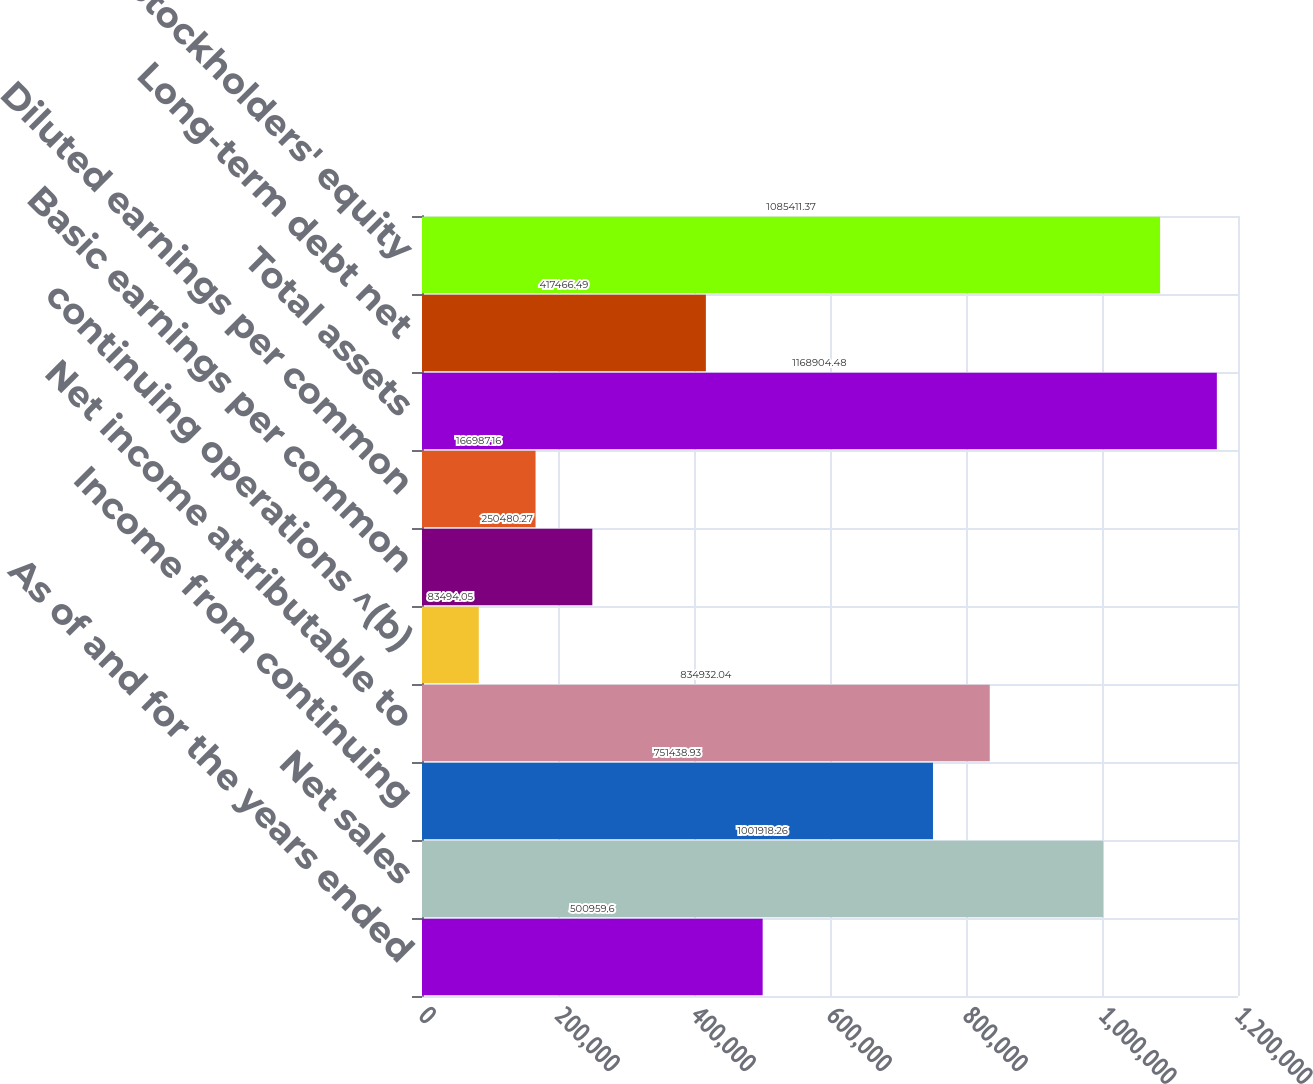Convert chart. <chart><loc_0><loc_0><loc_500><loc_500><bar_chart><fcel>As of and for the years ended<fcel>Net sales<fcel>Income from continuing<fcel>Net income attributable to<fcel>continuing operations ^(b)<fcel>Basic earnings per common<fcel>Diluted earnings per common<fcel>Total assets<fcel>Long-term debt net<fcel>Stockholders' equity<nl><fcel>500960<fcel>1.00192e+06<fcel>751439<fcel>834932<fcel>83494.1<fcel>250480<fcel>166987<fcel>1.1689e+06<fcel>417466<fcel>1.08541e+06<nl></chart> 